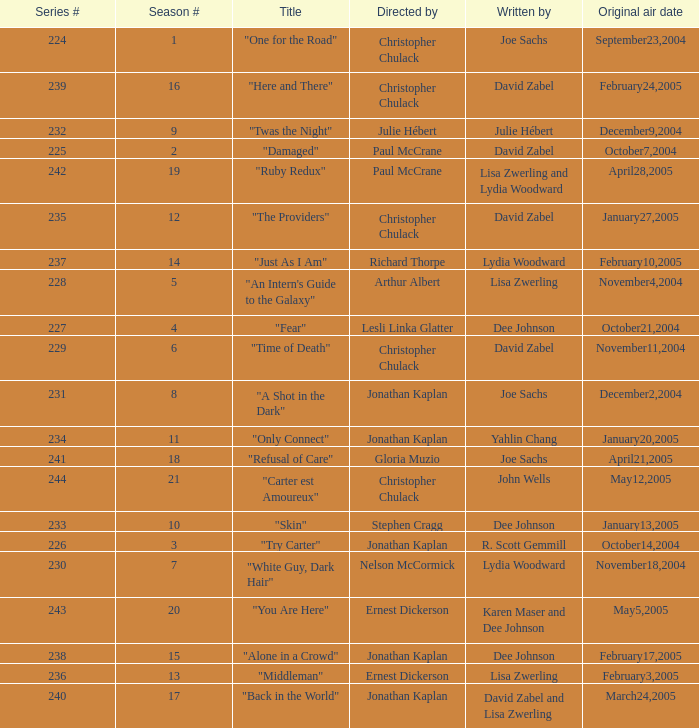Can you parse all the data within this table? {'header': ['Series #', 'Season #', 'Title', 'Directed by', 'Written by', 'Original air date'], 'rows': [['224', '1', '"One for the Road"', 'Christopher Chulack', 'Joe Sachs', 'September23,2004'], ['239', '16', '"Here and There"', 'Christopher Chulack', 'David Zabel', 'February24,2005'], ['232', '9', '"Twas the Night"', 'Julie Hébert', 'Julie Hébert', 'December9,2004'], ['225', '2', '"Damaged"', 'Paul McCrane', 'David Zabel', 'October7,2004'], ['242', '19', '"Ruby Redux"', 'Paul McCrane', 'Lisa Zwerling and Lydia Woodward', 'April28,2005'], ['235', '12', '"The Providers"', 'Christopher Chulack', 'David Zabel', 'January27,2005'], ['237', '14', '"Just As I Am"', 'Richard Thorpe', 'Lydia Woodward', 'February10,2005'], ['228', '5', '"An Intern\'s Guide to the Galaxy"', 'Arthur Albert', 'Lisa Zwerling', 'November4,2004'], ['227', '4', '"Fear"', 'Lesli Linka Glatter', 'Dee Johnson', 'October21,2004'], ['229', '6', '"Time of Death"', 'Christopher Chulack', 'David Zabel', 'November11,2004'], ['231', '8', '"A Shot in the Dark"', 'Jonathan Kaplan', 'Joe Sachs', 'December2,2004'], ['234', '11', '"Only Connect"', 'Jonathan Kaplan', 'Yahlin Chang', 'January20,2005'], ['241', '18', '"Refusal of Care"', 'Gloria Muzio', 'Joe Sachs', 'April21,2005'], ['244', '21', '"Carter est Amoureux"', 'Christopher Chulack', 'John Wells', 'May12,2005'], ['233', '10', '"Skin"', 'Stephen Cragg', 'Dee Johnson', 'January13,2005'], ['226', '3', '"Try Carter"', 'Jonathan Kaplan', 'R. Scott Gemmill', 'October14,2004'], ['230', '7', '"White Guy, Dark Hair"', 'Nelson McCormick', 'Lydia Woodward', 'November18,2004'], ['243', '20', '"You Are Here"', 'Ernest Dickerson', 'Karen Maser and Dee Johnson', 'May5,2005'], ['238', '15', '"Alone in a Crowd"', 'Jonathan Kaplan', 'Dee Johnson', 'February17,2005'], ['236', '13', '"Middleman"', 'Ernest Dickerson', 'Lisa Zwerling', 'February3,2005'], ['240', '17', '"Back in the World"', 'Jonathan Kaplan', 'David Zabel and Lisa Zwerling', 'March24,2005']]} Name the title that was written by r. scott gemmill "Try Carter". 